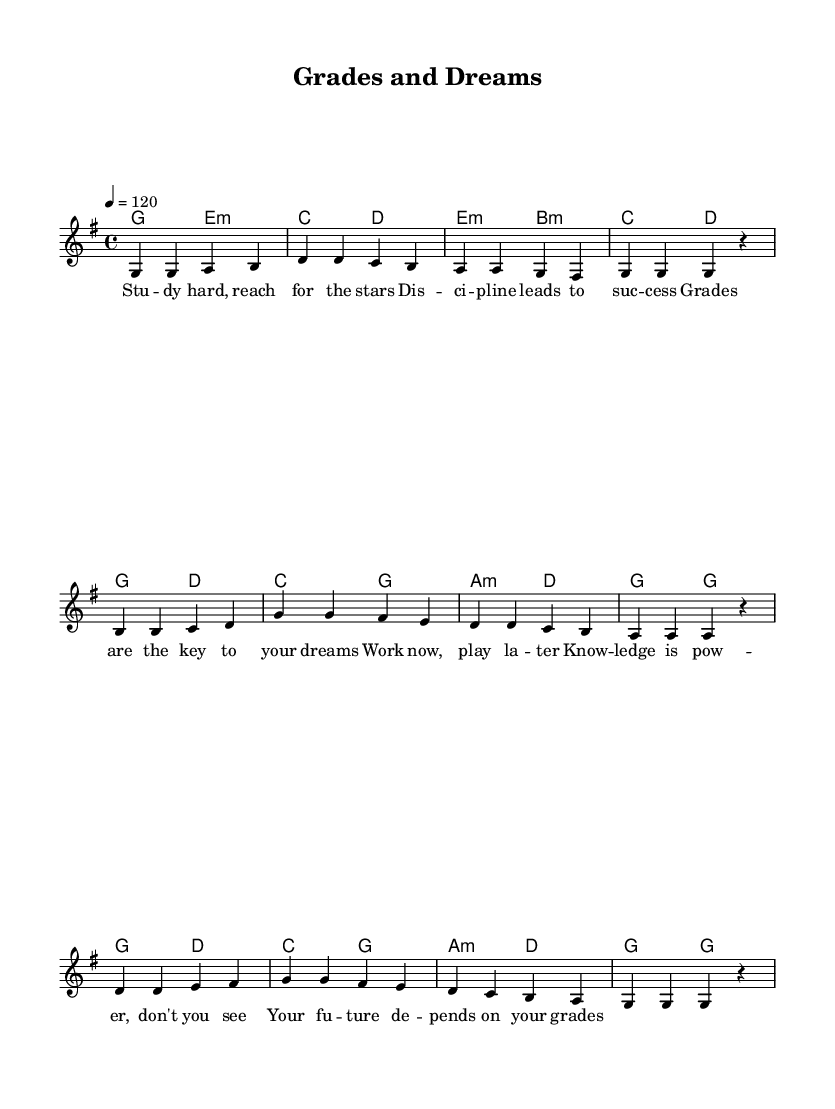What is the key signature of this music? The key signature shown at the beginning of the piece indicates G major, which has one sharp (F#).
Answer: G major What is the time signature of this music? The time signature indicated at the beginning is 4/4, meaning there are four beats per measure and the quarter note gets one beat.
Answer: 4/4 What is the tempo marking for this piece? The tempo marking is indicated as quarter note equals 120 beats per minute, meaning the piece should be played at a moderately fast pace.
Answer: 120 How many measures are there in the melody? Counting the measures from the staff, there are 10 measures in total in the melody.
Answer: 10 What is the main theme of the lyrics? The lyrics emphasize hard work and discipline as essential for achieving success, noting the importance of grades in reaching one’s dreams.
Answer: Hard work and discipline What is the structure of the harmony in this piece? The harmonies follow a chord progression typical for pop music, where chords resolve and move through different keys, creating an uplifting sound that supports the melodic line.
Answer: Chord progression What K-Pop characteristic is reflected in the lyrics? The lyrics reflect a common theme found in K-Pop emphasizing aspiration and self-discipline, aligning with the genre’s focus on youthful ambition and dedication to success.
Answer: Aspiration and self-discipline 